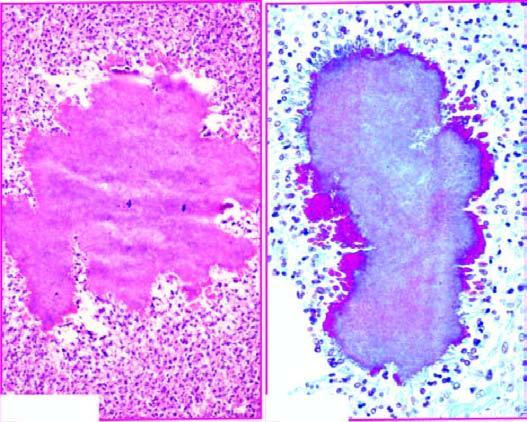what shows hyaline filaments highlighted by masson 's trichrome stain right photomicrograph?
Answer the question using a single word or phrase. The margin of the colony 